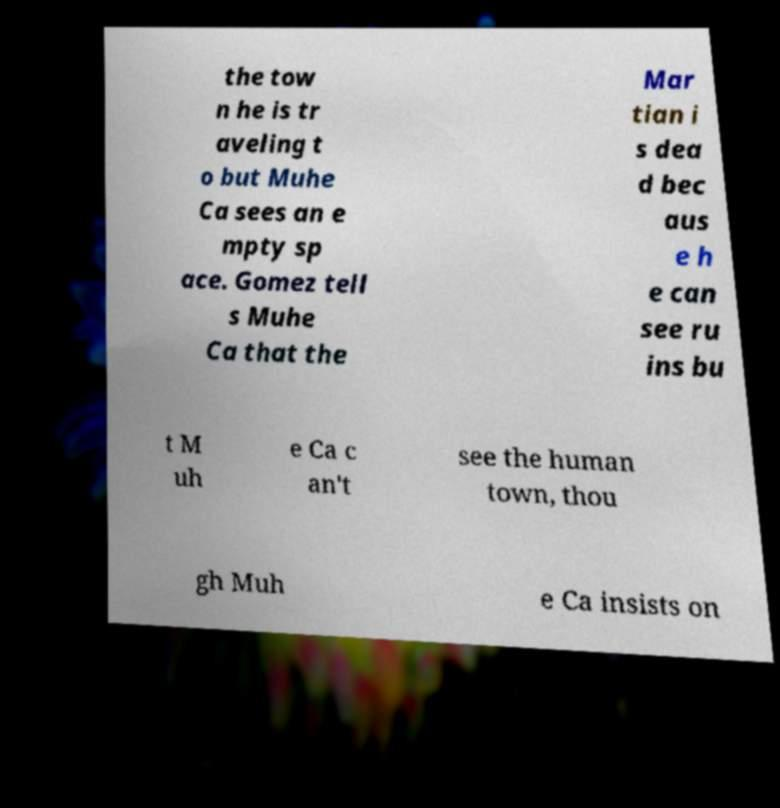Could you assist in decoding the text presented in this image and type it out clearly? the tow n he is tr aveling t o but Muhe Ca sees an e mpty sp ace. Gomez tell s Muhe Ca that the Mar tian i s dea d bec aus e h e can see ru ins bu t M uh e Ca c an't see the human town, thou gh Muh e Ca insists on 